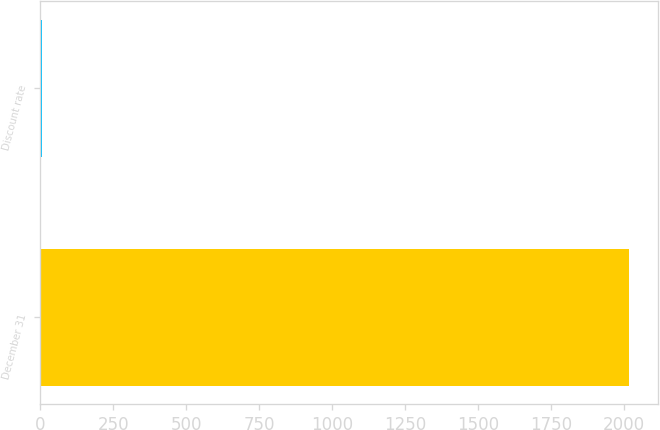<chart> <loc_0><loc_0><loc_500><loc_500><bar_chart><fcel>December 31<fcel>Discount rate<nl><fcel>2016<fcel>4<nl></chart> 